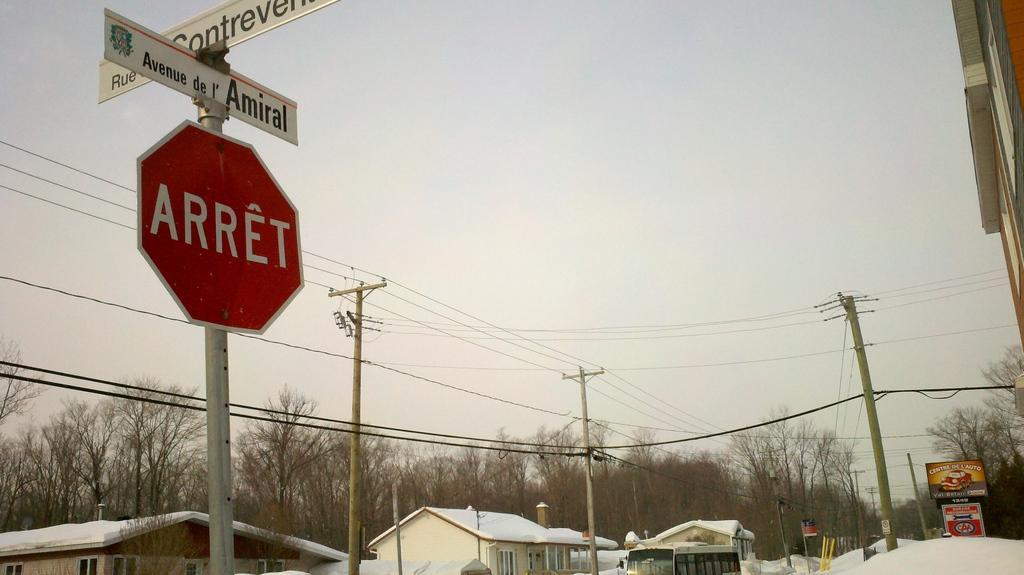Could you give a brief overview of what you see in this image? In this picture we can observe a red color board fixed to the pole and there are two white color boards. We can observe some service poles and some wires. There are some houses on which we can observe snow. In the background there are trees and a sky. 